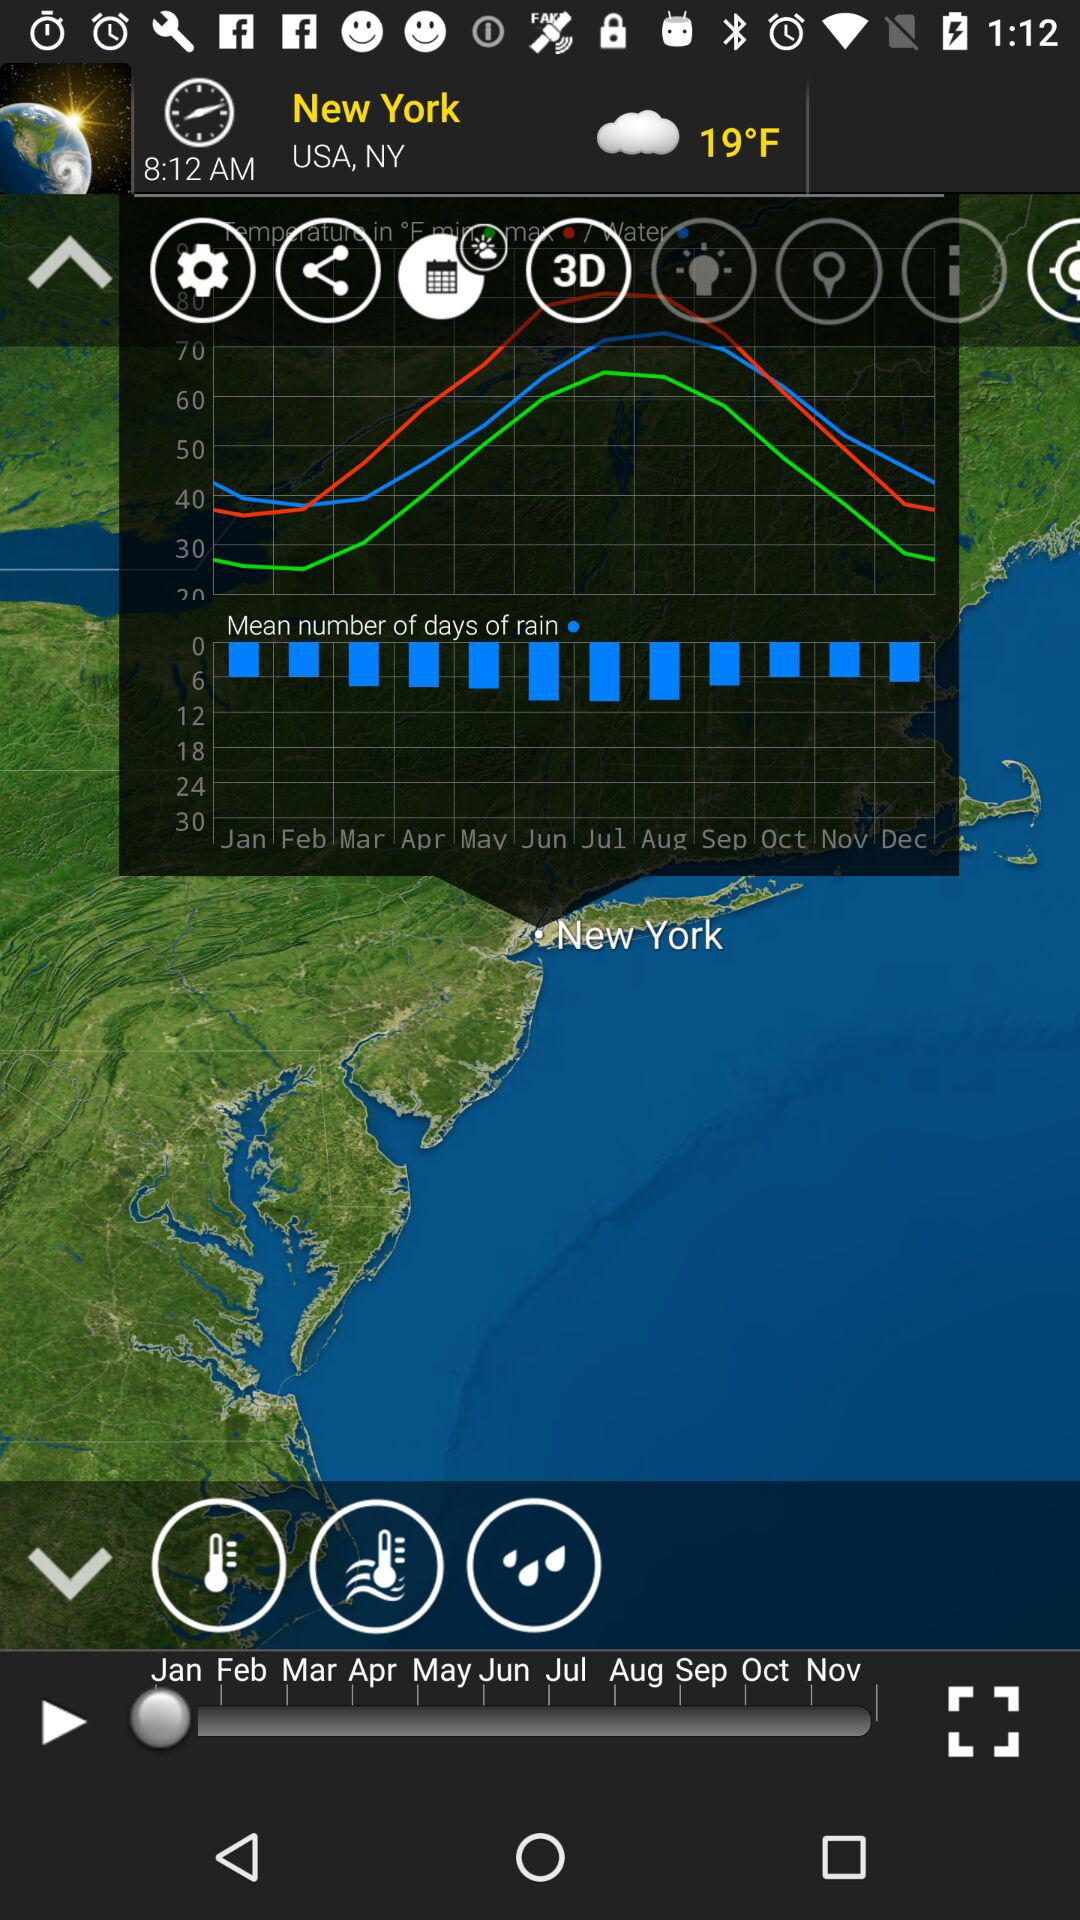What is the year?
When the provided information is insufficient, respond with <no answer>. <no answer> 